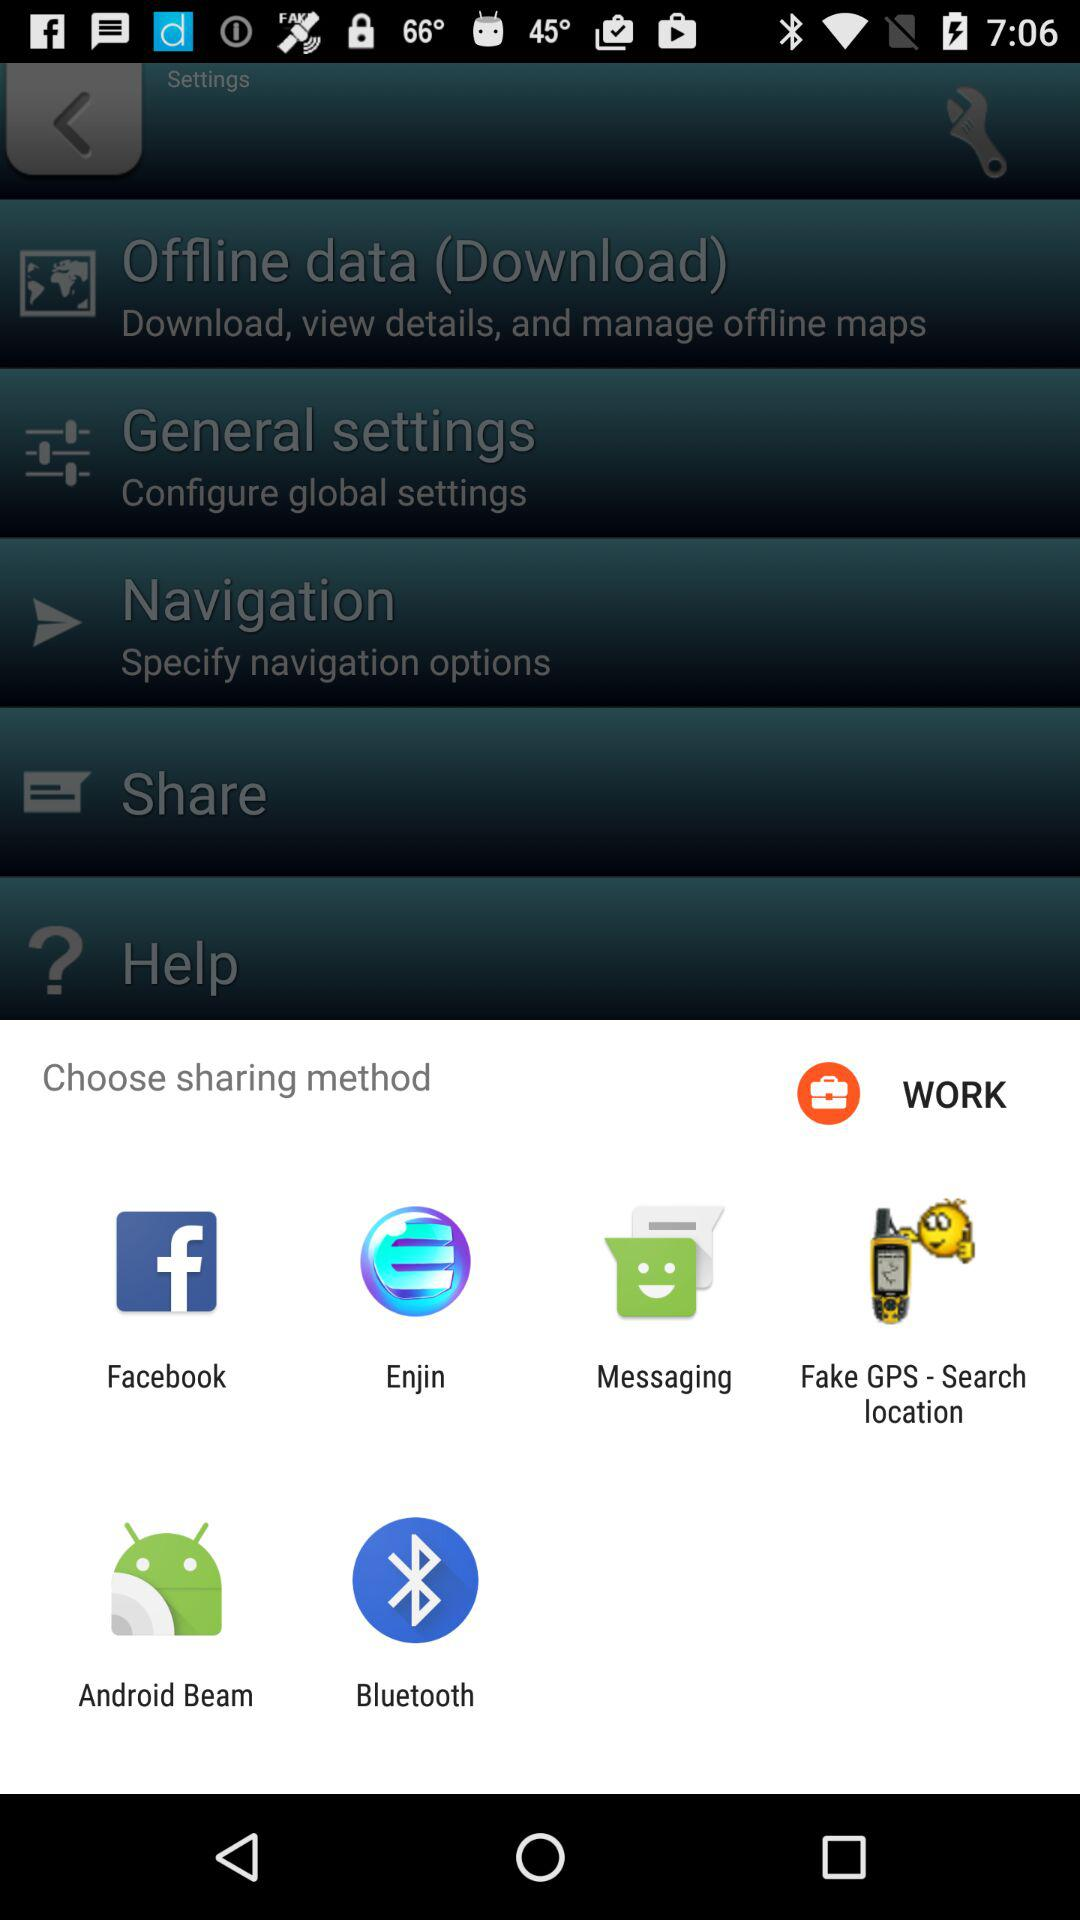What is the status of "Share"?
When the provided information is insufficient, respond with <no answer>. <no answer> 